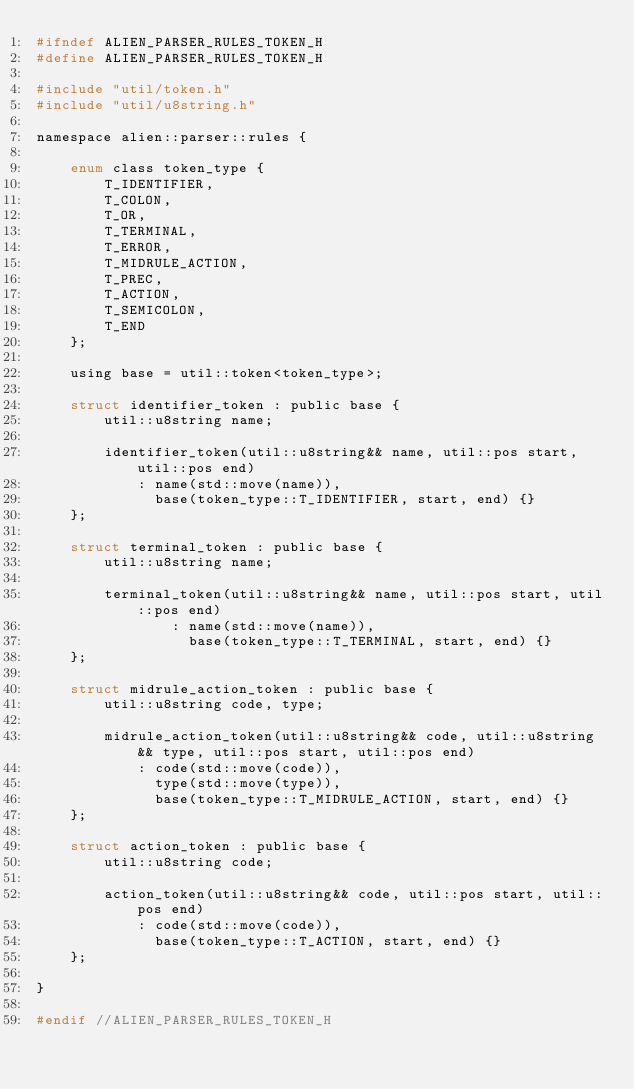<code> <loc_0><loc_0><loc_500><loc_500><_C_>#ifndef ALIEN_PARSER_RULES_TOKEN_H
#define ALIEN_PARSER_RULES_TOKEN_H

#include "util/token.h"
#include "util/u8string.h"

namespace alien::parser::rules {

    enum class token_type {
        T_IDENTIFIER,
        T_COLON,
        T_OR,
        T_TERMINAL,
        T_ERROR,
        T_MIDRULE_ACTION,
        T_PREC,
        T_ACTION,
        T_SEMICOLON,
        T_END
    };

    using base = util::token<token_type>;

    struct identifier_token : public base {
        util::u8string name;

        identifier_token(util::u8string&& name, util::pos start, util::pos end)
            : name(std::move(name)),
              base(token_type::T_IDENTIFIER, start, end) {}
    };

    struct terminal_token : public base {
        util::u8string name;

        terminal_token(util::u8string&& name, util::pos start, util::pos end)
                : name(std::move(name)),
                  base(token_type::T_TERMINAL, start, end) {}
    };

    struct midrule_action_token : public base {
        util::u8string code, type;

        midrule_action_token(util::u8string&& code, util::u8string&& type, util::pos start, util::pos end)
            : code(std::move(code)),
              type(std::move(type)),
              base(token_type::T_MIDRULE_ACTION, start, end) {}
    };

    struct action_token : public base {
        util::u8string code;

        action_token(util::u8string&& code, util::pos start, util::pos end)
            : code(std::move(code)),
              base(token_type::T_ACTION, start, end) {}
    };

}

#endif //ALIEN_PARSER_RULES_TOKEN_H</code> 